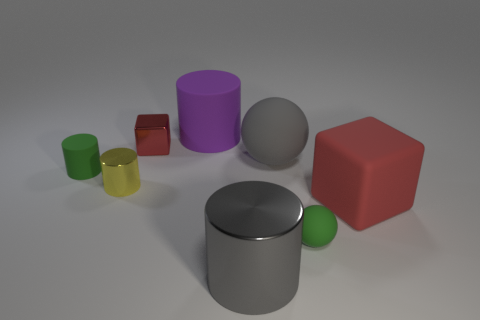Does the shiny thing that is in front of the matte block have the same size as the small yellow thing?
Keep it short and to the point. No. How many rubber things are green objects or large purple cylinders?
Ensure brevity in your answer.  3. How big is the object that is on the right side of the green rubber sphere?
Ensure brevity in your answer.  Large. Do the yellow metal thing and the small red object have the same shape?
Provide a succinct answer. No. How many small objects are green rubber cylinders or gray matte blocks?
Offer a very short reply. 1. There is a big red matte object; are there any things right of it?
Provide a short and direct response. No. Is the number of red matte things that are behind the gray ball the same as the number of small rubber balls?
Ensure brevity in your answer.  No. What size is the green matte object that is the same shape as the big gray metal thing?
Give a very brief answer. Small. Do the purple rubber thing and the tiny object that is to the right of the big purple matte thing have the same shape?
Your answer should be compact. No. What size is the metal object that is behind the gray ball on the right side of the gray shiny cylinder?
Give a very brief answer. Small. 